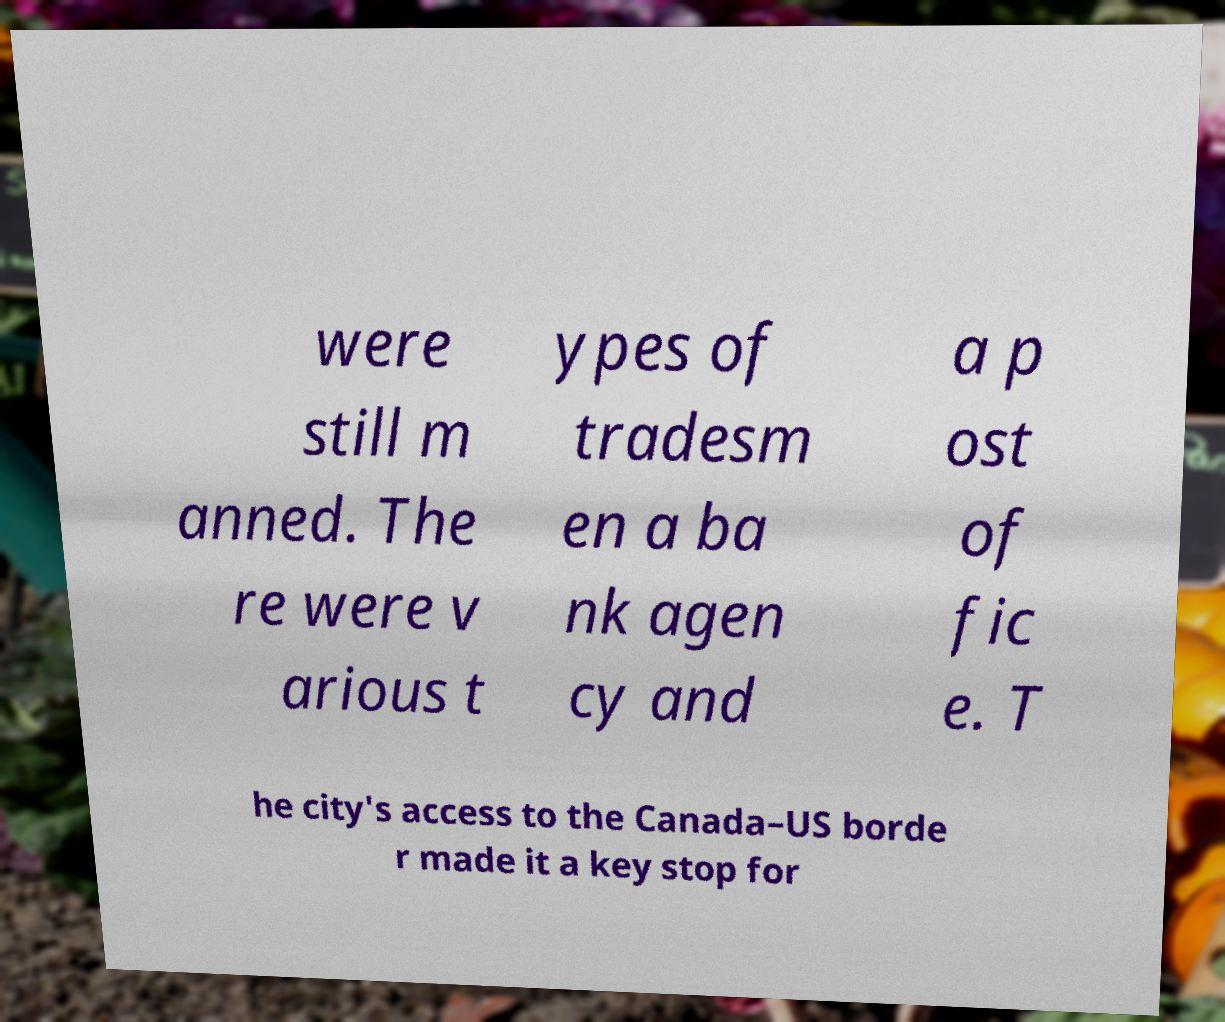I need the written content from this picture converted into text. Can you do that? were still m anned. The re were v arious t ypes of tradesm en a ba nk agen cy and a p ost of fic e. T he city's access to the Canada–US borde r made it a key stop for 